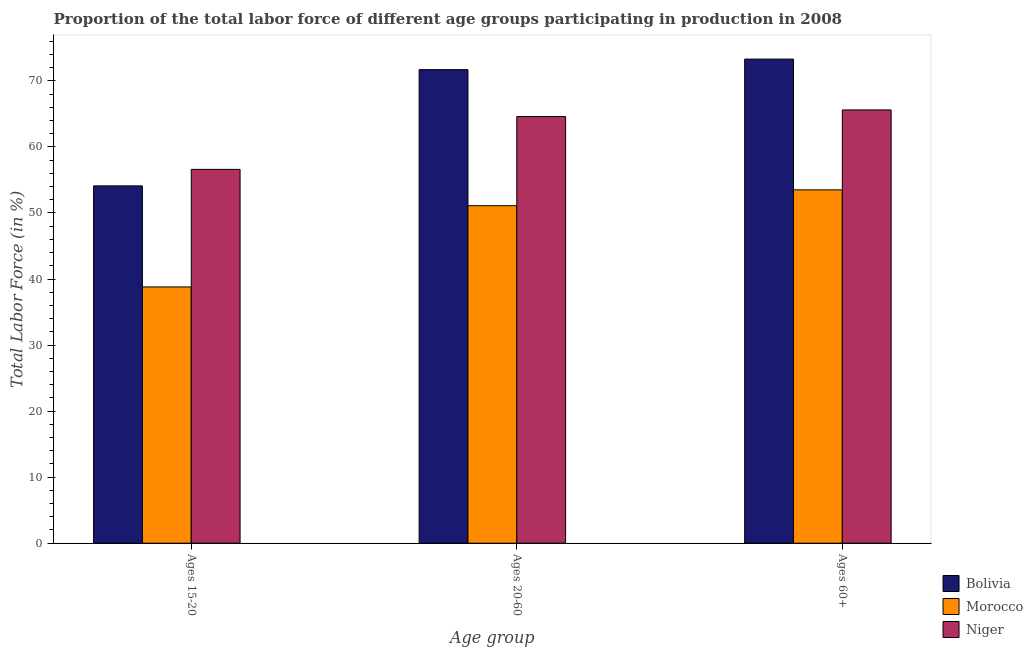How many groups of bars are there?
Provide a short and direct response. 3. What is the label of the 1st group of bars from the left?
Offer a terse response. Ages 15-20. What is the percentage of labor force above age 60 in Bolivia?
Provide a succinct answer. 73.3. Across all countries, what is the maximum percentage of labor force above age 60?
Provide a succinct answer. 73.3. Across all countries, what is the minimum percentage of labor force within the age group 20-60?
Ensure brevity in your answer.  51.1. In which country was the percentage of labor force within the age group 20-60 maximum?
Offer a very short reply. Bolivia. In which country was the percentage of labor force above age 60 minimum?
Ensure brevity in your answer.  Morocco. What is the total percentage of labor force within the age group 15-20 in the graph?
Your answer should be compact. 149.5. What is the difference between the percentage of labor force within the age group 20-60 in Morocco and that in Bolivia?
Make the answer very short. -20.6. What is the difference between the percentage of labor force within the age group 20-60 in Niger and the percentage of labor force above age 60 in Bolivia?
Offer a terse response. -8.7. What is the average percentage of labor force within the age group 20-60 per country?
Your response must be concise. 62.47. What is the difference between the percentage of labor force within the age group 15-20 and percentage of labor force within the age group 20-60 in Bolivia?
Your answer should be very brief. -17.6. In how many countries, is the percentage of labor force within the age group 15-20 greater than 24 %?
Provide a short and direct response. 3. What is the ratio of the percentage of labor force within the age group 15-20 in Niger to that in Morocco?
Make the answer very short. 1.46. Is the percentage of labor force within the age group 15-20 in Bolivia less than that in Morocco?
Offer a terse response. No. What is the difference between the highest and the lowest percentage of labor force above age 60?
Provide a succinct answer. 19.8. Is the sum of the percentage of labor force above age 60 in Morocco and Bolivia greater than the maximum percentage of labor force within the age group 20-60 across all countries?
Offer a terse response. Yes. What does the 2nd bar from the left in Ages 15-20 represents?
Your response must be concise. Morocco. What does the 2nd bar from the right in Ages 15-20 represents?
Offer a very short reply. Morocco. How many bars are there?
Ensure brevity in your answer.  9. How many countries are there in the graph?
Give a very brief answer. 3. Are the values on the major ticks of Y-axis written in scientific E-notation?
Your response must be concise. No. Does the graph contain any zero values?
Provide a succinct answer. No. Where does the legend appear in the graph?
Provide a short and direct response. Bottom right. How many legend labels are there?
Offer a terse response. 3. How are the legend labels stacked?
Make the answer very short. Vertical. What is the title of the graph?
Provide a short and direct response. Proportion of the total labor force of different age groups participating in production in 2008. Does "Eritrea" appear as one of the legend labels in the graph?
Make the answer very short. No. What is the label or title of the X-axis?
Your response must be concise. Age group. What is the Total Labor Force (in %) of Bolivia in Ages 15-20?
Provide a short and direct response. 54.1. What is the Total Labor Force (in %) of Morocco in Ages 15-20?
Ensure brevity in your answer.  38.8. What is the Total Labor Force (in %) in Niger in Ages 15-20?
Give a very brief answer. 56.6. What is the Total Labor Force (in %) of Bolivia in Ages 20-60?
Give a very brief answer. 71.7. What is the Total Labor Force (in %) of Morocco in Ages 20-60?
Give a very brief answer. 51.1. What is the Total Labor Force (in %) in Niger in Ages 20-60?
Provide a succinct answer. 64.6. What is the Total Labor Force (in %) in Bolivia in Ages 60+?
Give a very brief answer. 73.3. What is the Total Labor Force (in %) of Morocco in Ages 60+?
Your answer should be very brief. 53.5. What is the Total Labor Force (in %) of Niger in Ages 60+?
Give a very brief answer. 65.6. Across all Age group, what is the maximum Total Labor Force (in %) in Bolivia?
Keep it short and to the point. 73.3. Across all Age group, what is the maximum Total Labor Force (in %) of Morocco?
Offer a terse response. 53.5. Across all Age group, what is the maximum Total Labor Force (in %) of Niger?
Keep it short and to the point. 65.6. Across all Age group, what is the minimum Total Labor Force (in %) of Bolivia?
Your answer should be very brief. 54.1. Across all Age group, what is the minimum Total Labor Force (in %) of Morocco?
Offer a very short reply. 38.8. Across all Age group, what is the minimum Total Labor Force (in %) of Niger?
Provide a succinct answer. 56.6. What is the total Total Labor Force (in %) in Bolivia in the graph?
Give a very brief answer. 199.1. What is the total Total Labor Force (in %) in Morocco in the graph?
Make the answer very short. 143.4. What is the total Total Labor Force (in %) of Niger in the graph?
Offer a very short reply. 186.8. What is the difference between the Total Labor Force (in %) in Bolivia in Ages 15-20 and that in Ages 20-60?
Provide a succinct answer. -17.6. What is the difference between the Total Labor Force (in %) in Bolivia in Ages 15-20 and that in Ages 60+?
Give a very brief answer. -19.2. What is the difference between the Total Labor Force (in %) of Morocco in Ages 15-20 and that in Ages 60+?
Your response must be concise. -14.7. What is the difference between the Total Labor Force (in %) in Bolivia in Ages 20-60 and that in Ages 60+?
Your answer should be very brief. -1.6. What is the difference between the Total Labor Force (in %) in Niger in Ages 20-60 and that in Ages 60+?
Your response must be concise. -1. What is the difference between the Total Labor Force (in %) in Morocco in Ages 15-20 and the Total Labor Force (in %) in Niger in Ages 20-60?
Make the answer very short. -25.8. What is the difference between the Total Labor Force (in %) of Bolivia in Ages 15-20 and the Total Labor Force (in %) of Niger in Ages 60+?
Offer a very short reply. -11.5. What is the difference between the Total Labor Force (in %) in Morocco in Ages 15-20 and the Total Labor Force (in %) in Niger in Ages 60+?
Give a very brief answer. -26.8. What is the difference between the Total Labor Force (in %) of Bolivia in Ages 20-60 and the Total Labor Force (in %) of Niger in Ages 60+?
Ensure brevity in your answer.  6.1. What is the difference between the Total Labor Force (in %) of Morocco in Ages 20-60 and the Total Labor Force (in %) of Niger in Ages 60+?
Your response must be concise. -14.5. What is the average Total Labor Force (in %) in Bolivia per Age group?
Your response must be concise. 66.37. What is the average Total Labor Force (in %) in Morocco per Age group?
Offer a very short reply. 47.8. What is the average Total Labor Force (in %) of Niger per Age group?
Offer a terse response. 62.27. What is the difference between the Total Labor Force (in %) of Bolivia and Total Labor Force (in %) of Morocco in Ages 15-20?
Give a very brief answer. 15.3. What is the difference between the Total Labor Force (in %) of Morocco and Total Labor Force (in %) of Niger in Ages 15-20?
Keep it short and to the point. -17.8. What is the difference between the Total Labor Force (in %) of Bolivia and Total Labor Force (in %) of Morocco in Ages 20-60?
Offer a very short reply. 20.6. What is the difference between the Total Labor Force (in %) in Bolivia and Total Labor Force (in %) in Niger in Ages 20-60?
Your answer should be very brief. 7.1. What is the difference between the Total Labor Force (in %) of Bolivia and Total Labor Force (in %) of Morocco in Ages 60+?
Your answer should be very brief. 19.8. What is the difference between the Total Labor Force (in %) in Bolivia and Total Labor Force (in %) in Niger in Ages 60+?
Make the answer very short. 7.7. What is the difference between the Total Labor Force (in %) in Morocco and Total Labor Force (in %) in Niger in Ages 60+?
Provide a short and direct response. -12.1. What is the ratio of the Total Labor Force (in %) of Bolivia in Ages 15-20 to that in Ages 20-60?
Ensure brevity in your answer.  0.75. What is the ratio of the Total Labor Force (in %) of Morocco in Ages 15-20 to that in Ages 20-60?
Keep it short and to the point. 0.76. What is the ratio of the Total Labor Force (in %) of Niger in Ages 15-20 to that in Ages 20-60?
Give a very brief answer. 0.88. What is the ratio of the Total Labor Force (in %) of Bolivia in Ages 15-20 to that in Ages 60+?
Your answer should be very brief. 0.74. What is the ratio of the Total Labor Force (in %) in Morocco in Ages 15-20 to that in Ages 60+?
Give a very brief answer. 0.73. What is the ratio of the Total Labor Force (in %) of Niger in Ages 15-20 to that in Ages 60+?
Your response must be concise. 0.86. What is the ratio of the Total Labor Force (in %) of Bolivia in Ages 20-60 to that in Ages 60+?
Make the answer very short. 0.98. What is the ratio of the Total Labor Force (in %) in Morocco in Ages 20-60 to that in Ages 60+?
Your response must be concise. 0.96. What is the difference between the highest and the second highest Total Labor Force (in %) of Bolivia?
Keep it short and to the point. 1.6. What is the difference between the highest and the second highest Total Labor Force (in %) in Niger?
Make the answer very short. 1. What is the difference between the highest and the lowest Total Labor Force (in %) in Morocco?
Keep it short and to the point. 14.7. 